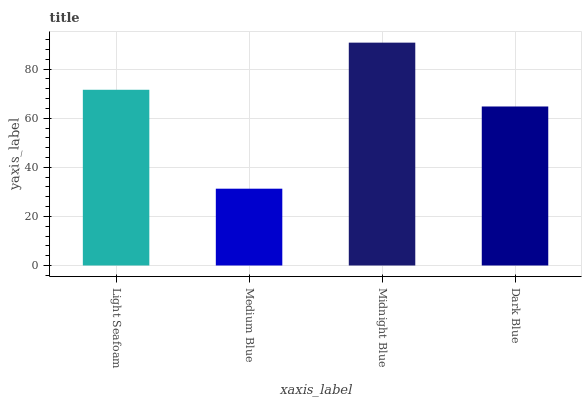Is Medium Blue the minimum?
Answer yes or no. Yes. Is Midnight Blue the maximum?
Answer yes or no. Yes. Is Midnight Blue the minimum?
Answer yes or no. No. Is Medium Blue the maximum?
Answer yes or no. No. Is Midnight Blue greater than Medium Blue?
Answer yes or no. Yes. Is Medium Blue less than Midnight Blue?
Answer yes or no. Yes. Is Medium Blue greater than Midnight Blue?
Answer yes or no. No. Is Midnight Blue less than Medium Blue?
Answer yes or no. No. Is Light Seafoam the high median?
Answer yes or no. Yes. Is Dark Blue the low median?
Answer yes or no. Yes. Is Medium Blue the high median?
Answer yes or no. No. Is Medium Blue the low median?
Answer yes or no. No. 